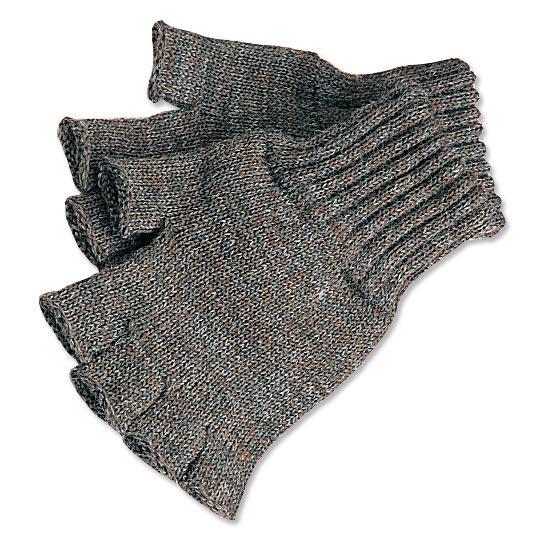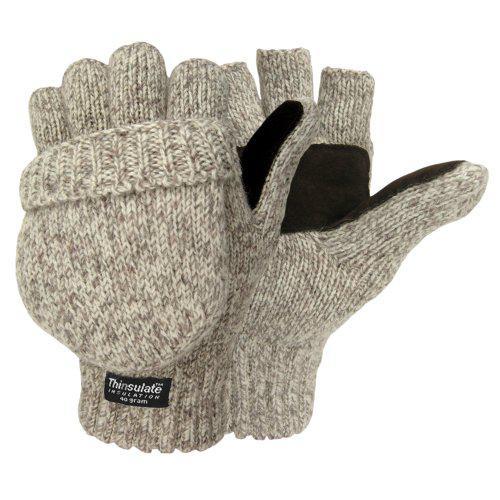The first image is the image on the left, the second image is the image on the right. Evaluate the accuracy of this statement regarding the images: "An image shows one fingerless glove over black """"fingers"""".". Is it true? Answer yes or no. No. The first image is the image on the left, the second image is the image on the right. Considering the images on both sides, is "Each image shows a complete pair of mittens." valid? Answer yes or no. Yes. 